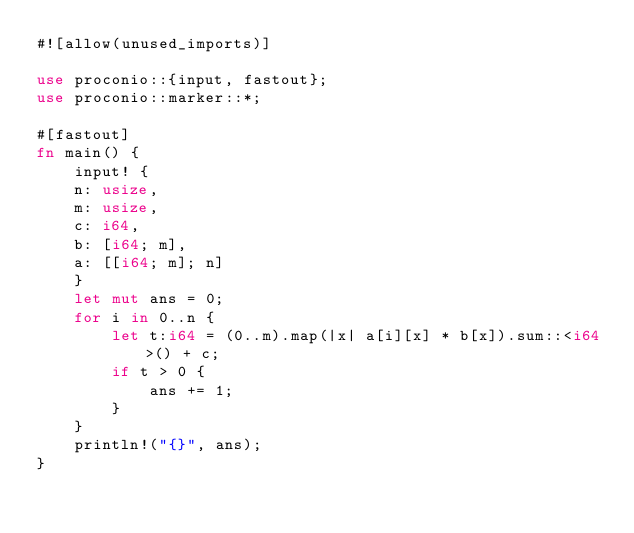Convert code to text. <code><loc_0><loc_0><loc_500><loc_500><_Rust_>#![allow(unused_imports)]

use proconio::{input, fastout};
use proconio::marker::*;

#[fastout]
fn main() {
    input! {
    n: usize,
    m: usize,
    c: i64,
    b: [i64; m],
    a: [[i64; m]; n]
    }
    let mut ans = 0;
    for i in 0..n {
        let t:i64 = (0..m).map(|x| a[i][x] * b[x]).sum::<i64>() + c;
        if t > 0 {
            ans += 1;
        }
    }
    println!("{}", ans);
}
</code> 